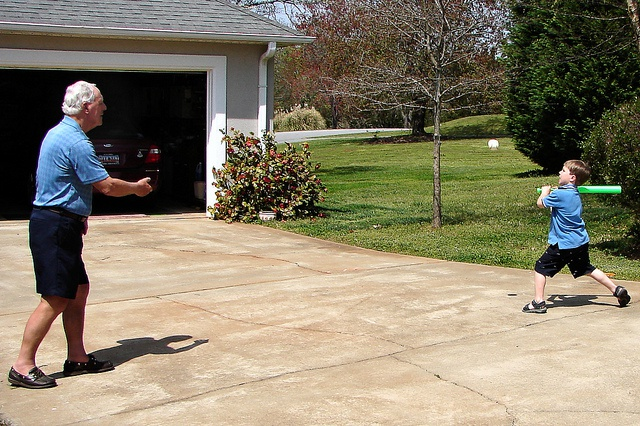Describe the objects in this image and their specific colors. I can see people in darkgray, black, maroon, and lightblue tones, people in darkgray, black, lightblue, and lightgray tones, car in darkgray, black, gray, maroon, and blue tones, baseball bat in darkgray, black, white, lightgreen, and aquamarine tones, and sports ball in darkgray, ivory, and tan tones in this image. 